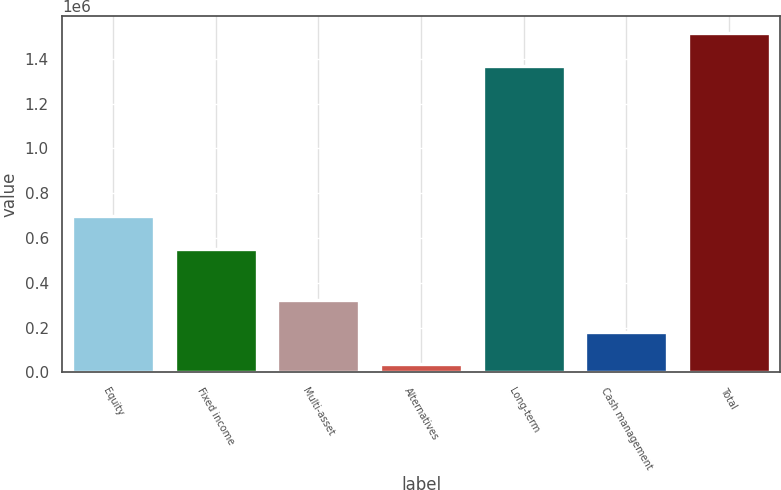<chart> <loc_0><loc_0><loc_500><loc_500><bar_chart><fcel>Equity<fcel>Fixed income<fcel>Multi-asset<fcel>Alternatives<fcel>Long-term<fcel>Cash management<fcel>Total<nl><fcel>696505<fcel>552352<fcel>325012<fcel>36707<fcel>1.36999e+06<fcel>180860<fcel>1.51414e+06<nl></chart> 